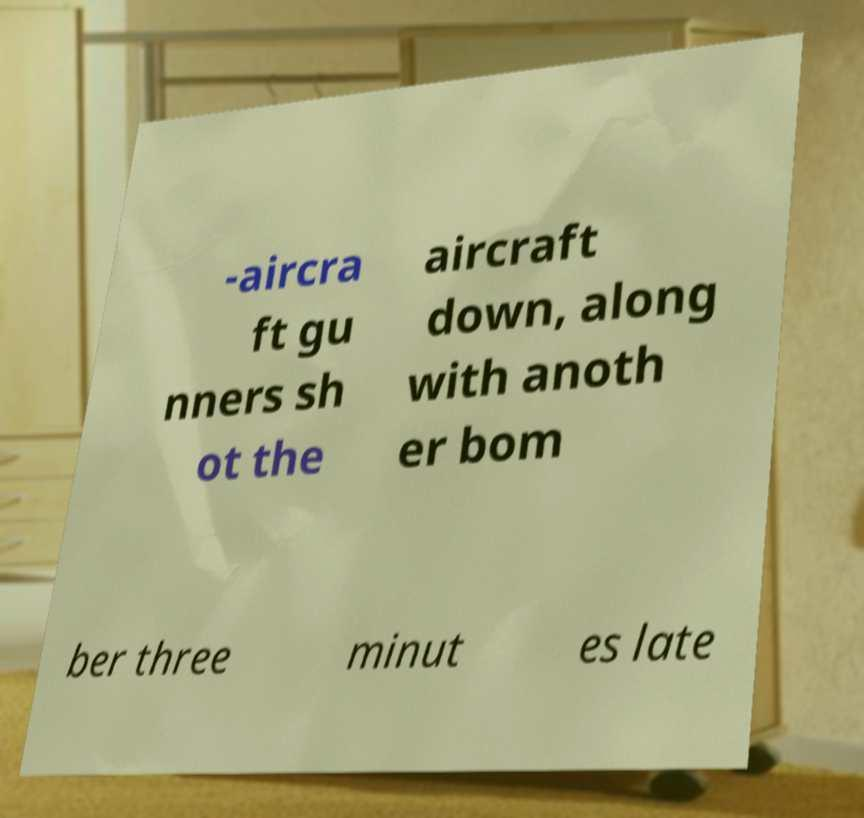Could you extract and type out the text from this image? -aircra ft gu nners sh ot the aircraft down, along with anoth er bom ber three minut es late 